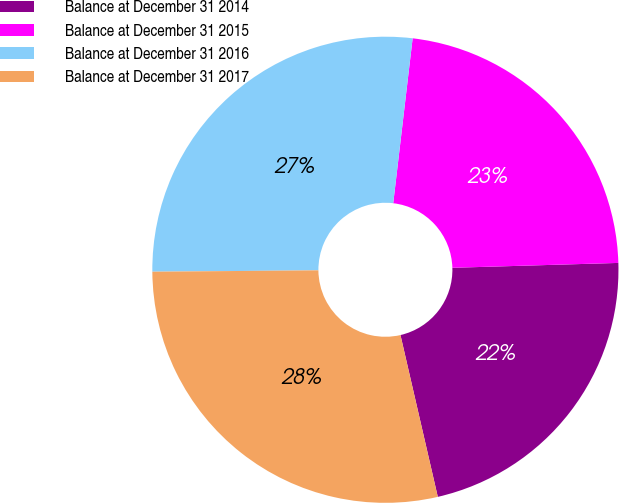Convert chart to OTSL. <chart><loc_0><loc_0><loc_500><loc_500><pie_chart><fcel>Balance at December 31 2014<fcel>Balance at December 31 2015<fcel>Balance at December 31 2016<fcel>Balance at December 31 2017<nl><fcel>21.86%<fcel>22.67%<fcel>27.0%<fcel>28.48%<nl></chart> 